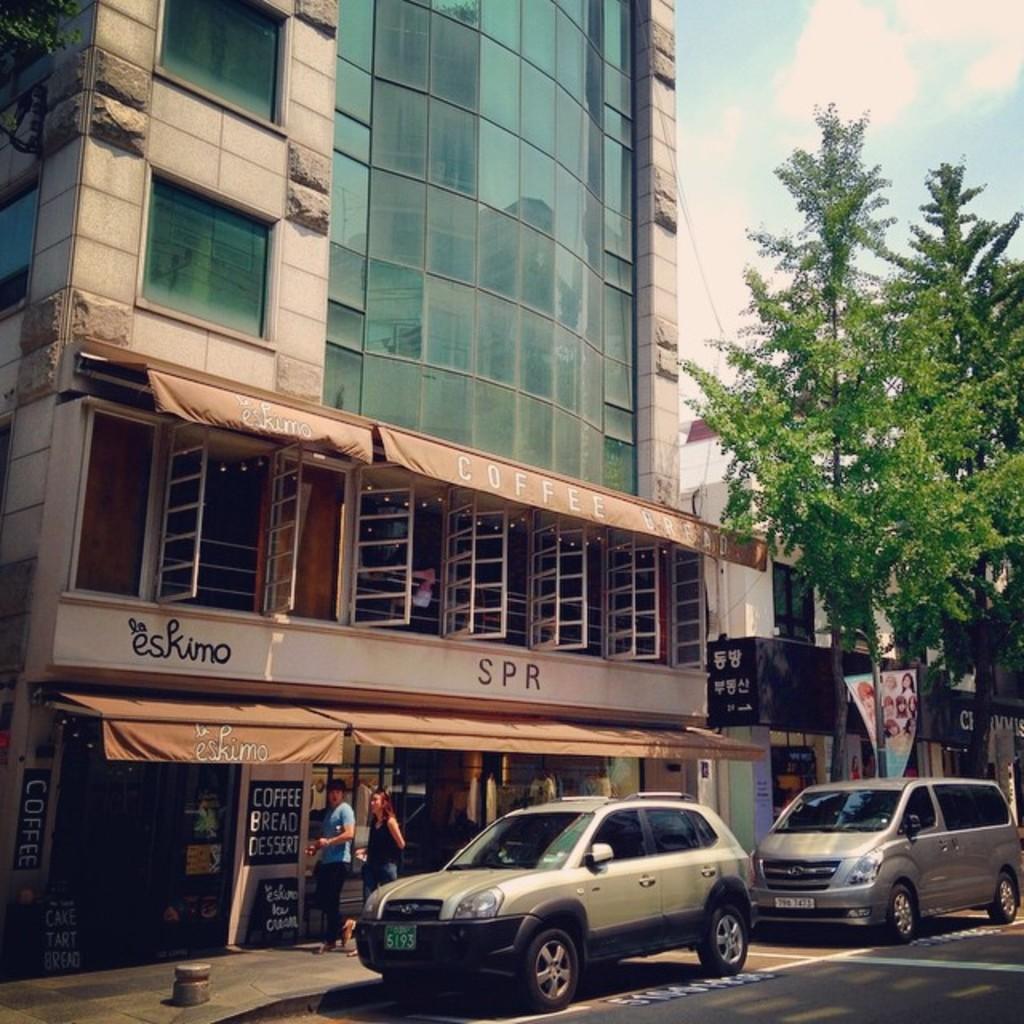Can you describe this image briefly? Here we can see buildings, tree, people, vehicles and hoarding. These are boards. To these buildings there are windows. 